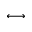Convert formula to latex. <formula><loc_0><loc_0><loc_500><loc_500>\longleftrightarrow</formula> 